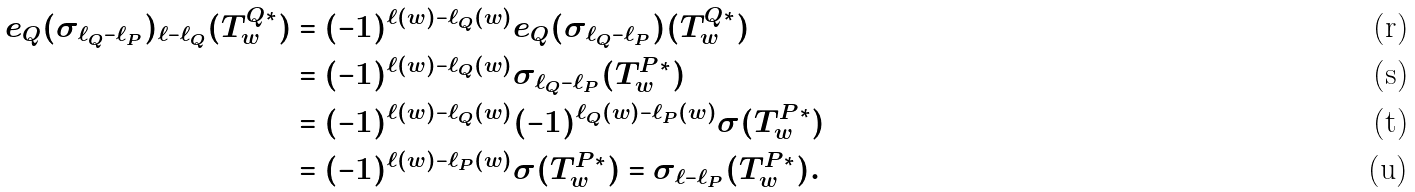<formula> <loc_0><loc_0><loc_500><loc_500>e _ { Q } ( \sigma _ { \ell _ { Q } - \ell _ { P } } ) _ { \ell - \ell _ { Q } } ( T _ { w } ^ { Q * } ) & = ( - 1 ) ^ { \ell ( w ) - \ell _ { Q } ( w ) } e _ { Q } ( \sigma _ { \ell _ { Q } - \ell _ { P } } ) ( T _ { w } ^ { Q * } ) \\ & = ( - 1 ) ^ { \ell ( w ) - \ell _ { Q } ( w ) } \sigma _ { \ell _ { Q } - \ell _ { P } } ( T _ { w } ^ { P * } ) \\ & = ( - 1 ) ^ { \ell ( w ) - \ell _ { Q } ( w ) } ( - 1 ) ^ { \ell _ { Q } ( w ) - \ell _ { P } ( w ) } \sigma ( T _ { w } ^ { P * } ) \\ & = ( - 1 ) ^ { \ell ( w ) - \ell _ { P } ( w ) } \sigma ( T _ { w } ^ { P * } ) = \sigma _ { \ell - \ell _ { P } } ( T _ { w } ^ { P * } ) .</formula> 